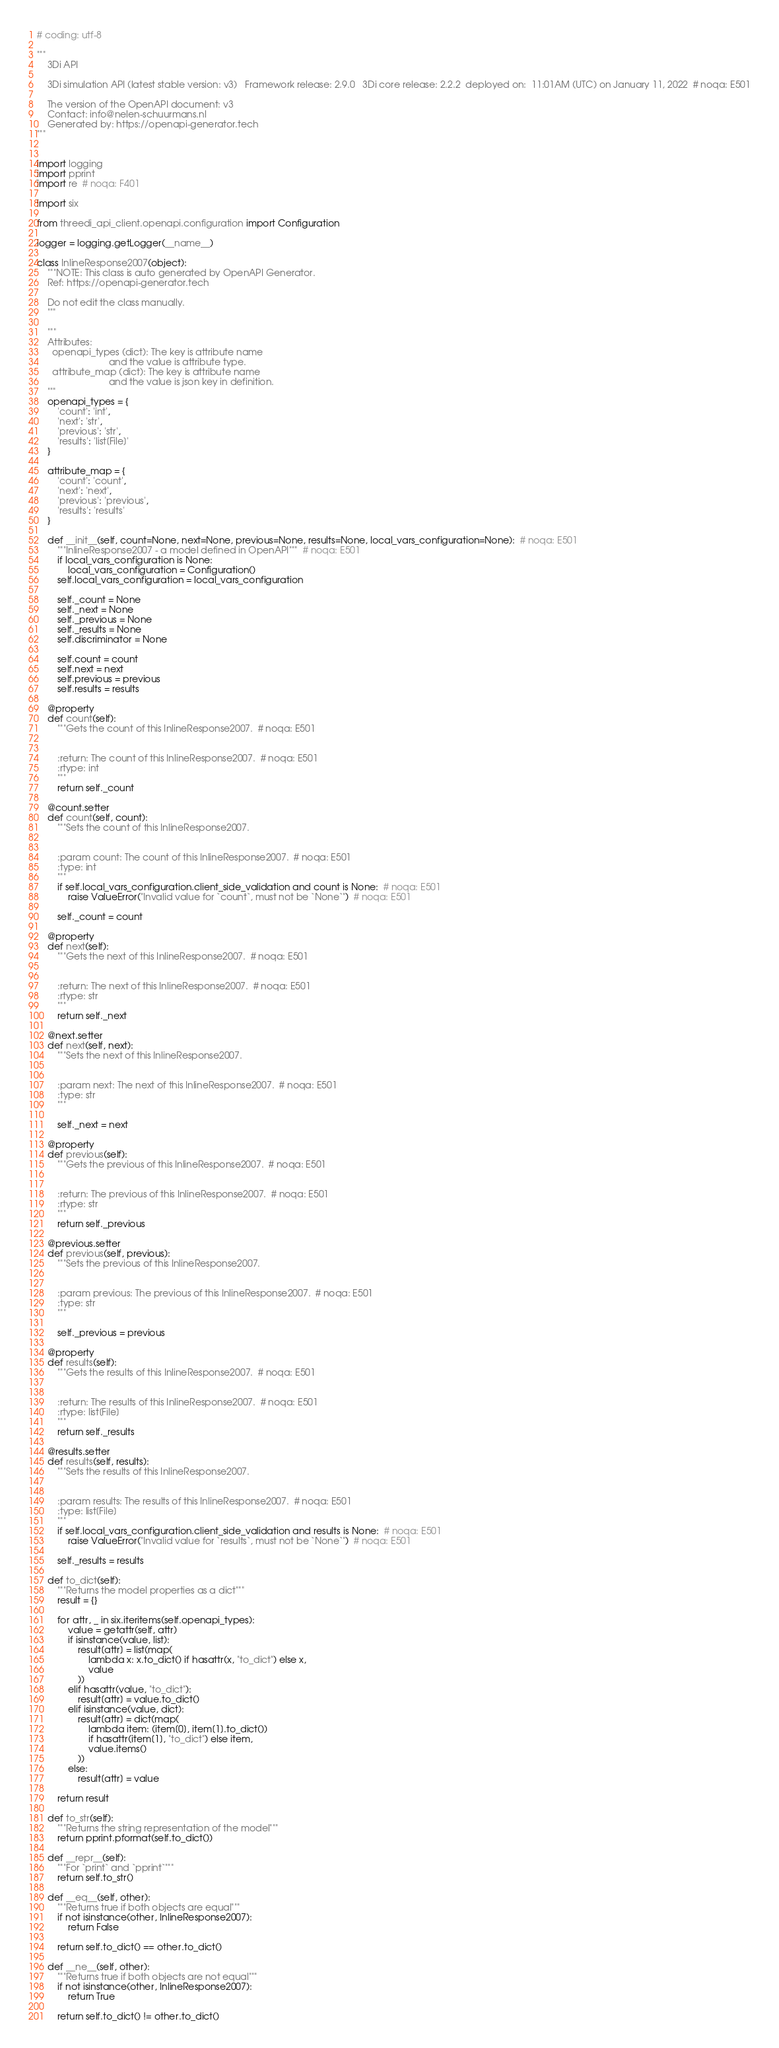Convert code to text. <code><loc_0><loc_0><loc_500><loc_500><_Python_># coding: utf-8

"""
    3Di API

    3Di simulation API (latest stable version: v3)   Framework release: 2.9.0   3Di core release: 2.2.2  deployed on:  11:01AM (UTC) on January 11, 2022  # noqa: E501

    The version of the OpenAPI document: v3
    Contact: info@nelen-schuurmans.nl
    Generated by: https://openapi-generator.tech
"""


import logging
import pprint
import re  # noqa: F401

import six

from threedi_api_client.openapi.configuration import Configuration

logger = logging.getLogger(__name__)

class InlineResponse2007(object):
    """NOTE: This class is auto generated by OpenAPI Generator.
    Ref: https://openapi-generator.tech

    Do not edit the class manually.
    """

    """
    Attributes:
      openapi_types (dict): The key is attribute name
                            and the value is attribute type.
      attribute_map (dict): The key is attribute name
                            and the value is json key in definition.
    """
    openapi_types = {
        'count': 'int',
        'next': 'str',
        'previous': 'str',
        'results': 'list[File]'
    }

    attribute_map = {
        'count': 'count',
        'next': 'next',
        'previous': 'previous',
        'results': 'results'
    }

    def __init__(self, count=None, next=None, previous=None, results=None, local_vars_configuration=None):  # noqa: E501
        """InlineResponse2007 - a model defined in OpenAPI"""  # noqa: E501
        if local_vars_configuration is None:
            local_vars_configuration = Configuration()
        self.local_vars_configuration = local_vars_configuration

        self._count = None
        self._next = None
        self._previous = None
        self._results = None
        self.discriminator = None

        self.count = count
        self.next = next
        self.previous = previous
        self.results = results

    @property
    def count(self):
        """Gets the count of this InlineResponse2007.  # noqa: E501


        :return: The count of this InlineResponse2007.  # noqa: E501
        :rtype: int
        """
        return self._count

    @count.setter
    def count(self, count):
        """Sets the count of this InlineResponse2007.


        :param count: The count of this InlineResponse2007.  # noqa: E501
        :type: int
        """
        if self.local_vars_configuration.client_side_validation and count is None:  # noqa: E501
            raise ValueError("Invalid value for `count`, must not be `None`")  # noqa: E501

        self._count = count

    @property
    def next(self):
        """Gets the next of this InlineResponse2007.  # noqa: E501


        :return: The next of this InlineResponse2007.  # noqa: E501
        :rtype: str
        """
        return self._next

    @next.setter
    def next(self, next):
        """Sets the next of this InlineResponse2007.


        :param next: The next of this InlineResponse2007.  # noqa: E501
        :type: str
        """

        self._next = next

    @property
    def previous(self):
        """Gets the previous of this InlineResponse2007.  # noqa: E501


        :return: The previous of this InlineResponse2007.  # noqa: E501
        :rtype: str
        """
        return self._previous

    @previous.setter
    def previous(self, previous):
        """Sets the previous of this InlineResponse2007.


        :param previous: The previous of this InlineResponse2007.  # noqa: E501
        :type: str
        """

        self._previous = previous

    @property
    def results(self):
        """Gets the results of this InlineResponse2007.  # noqa: E501


        :return: The results of this InlineResponse2007.  # noqa: E501
        :rtype: list[File]
        """
        return self._results

    @results.setter
    def results(self, results):
        """Sets the results of this InlineResponse2007.


        :param results: The results of this InlineResponse2007.  # noqa: E501
        :type: list[File]
        """
        if self.local_vars_configuration.client_side_validation and results is None:  # noqa: E501
            raise ValueError("Invalid value for `results`, must not be `None`")  # noqa: E501

        self._results = results

    def to_dict(self):
        """Returns the model properties as a dict"""
        result = {}

        for attr, _ in six.iteritems(self.openapi_types):
            value = getattr(self, attr)
            if isinstance(value, list):
                result[attr] = list(map(
                    lambda x: x.to_dict() if hasattr(x, "to_dict") else x,
                    value
                ))
            elif hasattr(value, "to_dict"):
                result[attr] = value.to_dict()
            elif isinstance(value, dict):
                result[attr] = dict(map(
                    lambda item: (item[0], item[1].to_dict())
                    if hasattr(item[1], "to_dict") else item,
                    value.items()
                ))
            else:
                result[attr] = value

        return result

    def to_str(self):
        """Returns the string representation of the model"""
        return pprint.pformat(self.to_dict())

    def __repr__(self):
        """For `print` and `pprint`"""
        return self.to_str()

    def __eq__(self, other):
        """Returns true if both objects are equal"""
        if not isinstance(other, InlineResponse2007):
            return False

        return self.to_dict() == other.to_dict()

    def __ne__(self, other):
        """Returns true if both objects are not equal"""
        if not isinstance(other, InlineResponse2007):
            return True

        return self.to_dict() != other.to_dict()
</code> 